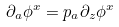Convert formula to latex. <formula><loc_0><loc_0><loc_500><loc_500>\partial _ { a } \phi ^ { x } = p _ { a } \partial _ { z } \phi ^ { x }</formula> 